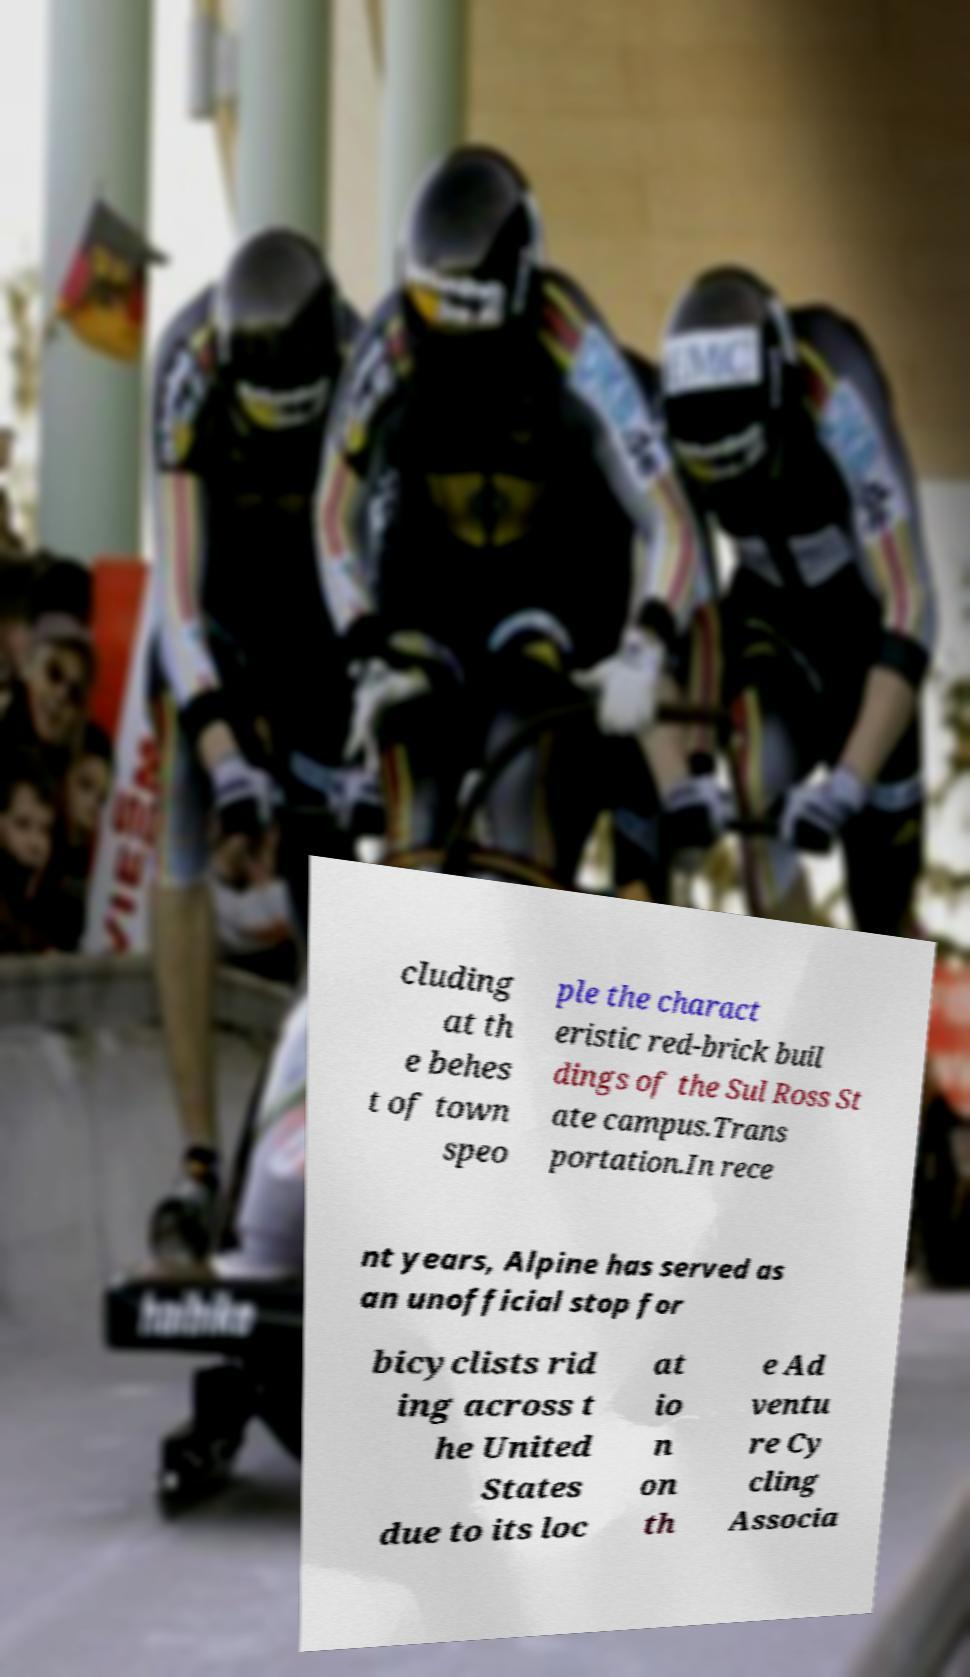Can you accurately transcribe the text from the provided image for me? cluding at th e behes t of town speo ple the charact eristic red-brick buil dings of the Sul Ross St ate campus.Trans portation.In rece nt years, Alpine has served as an unofficial stop for bicyclists rid ing across t he United States due to its loc at io n on th e Ad ventu re Cy cling Associa 